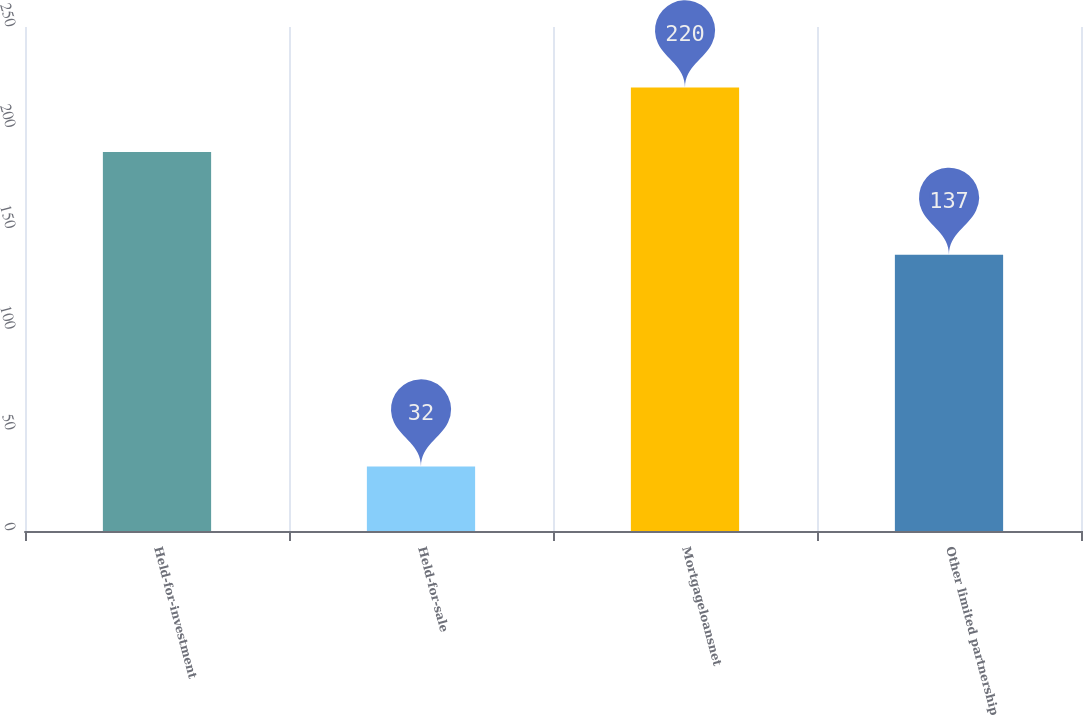<chart> <loc_0><loc_0><loc_500><loc_500><bar_chart><fcel>Held-for-investment<fcel>Held-for-sale<fcel>Mortgageloansnet<fcel>Other limited partnership<nl><fcel>188<fcel>32<fcel>220<fcel>137<nl></chart> 